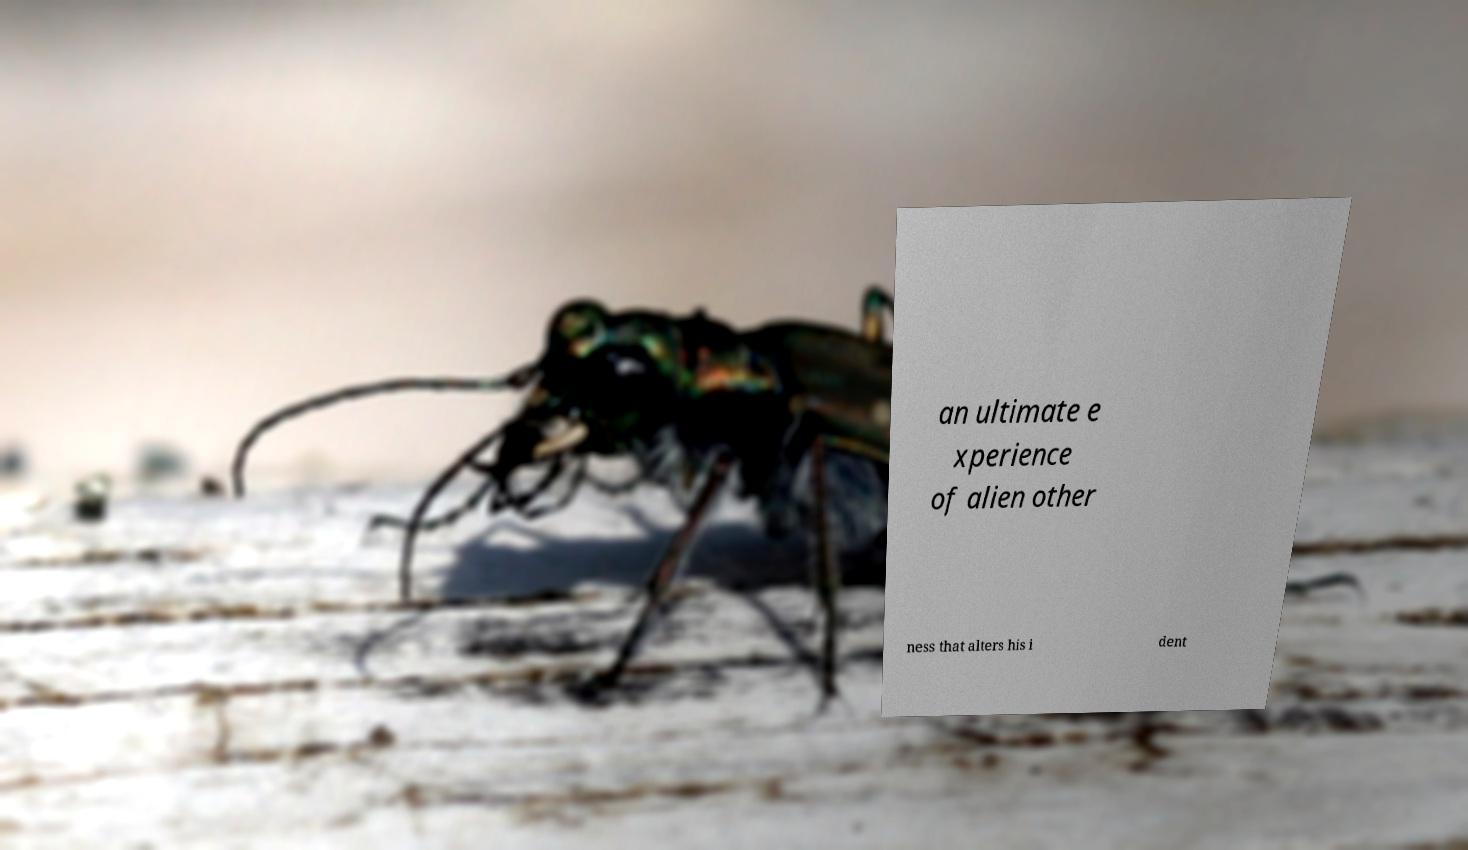Could you assist in decoding the text presented in this image and type it out clearly? an ultimate e xperience of alien other ness that alters his i dent 